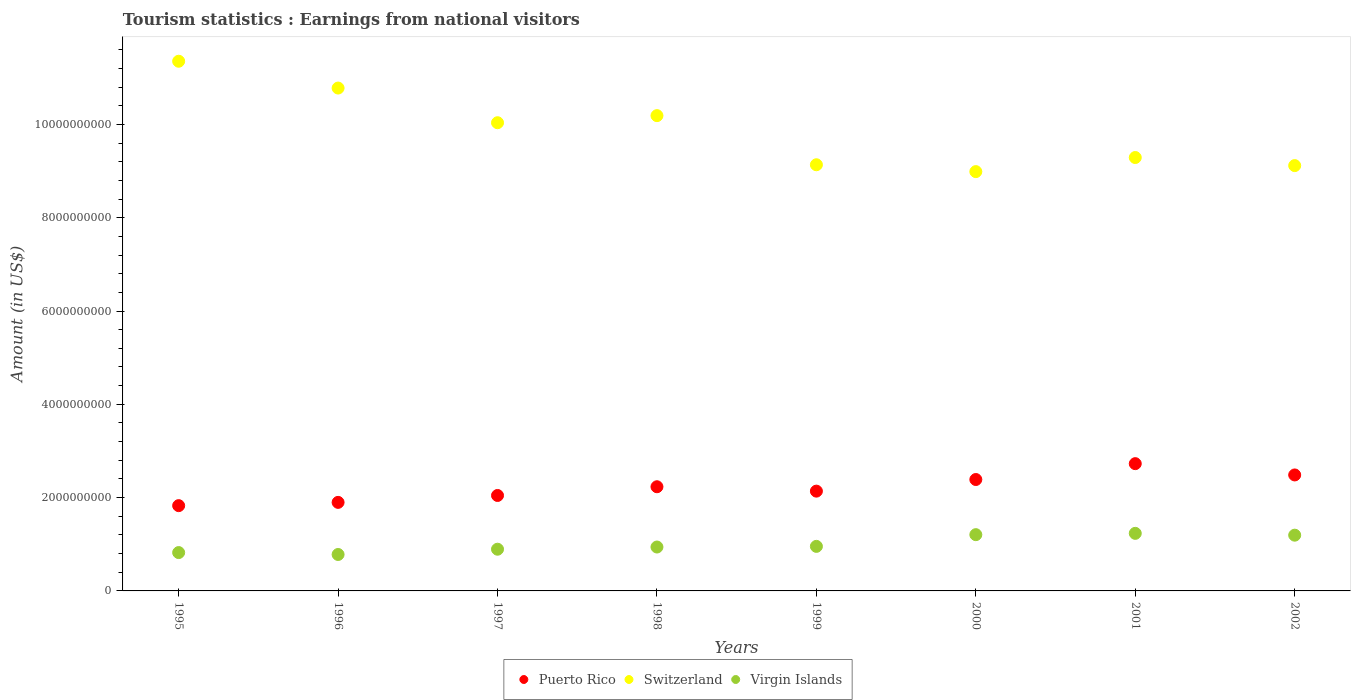How many different coloured dotlines are there?
Make the answer very short. 3. What is the earnings from national visitors in Puerto Rico in 2002?
Make the answer very short. 2.49e+09. Across all years, what is the maximum earnings from national visitors in Puerto Rico?
Your response must be concise. 2.73e+09. Across all years, what is the minimum earnings from national visitors in Puerto Rico?
Keep it short and to the point. 1.83e+09. In which year was the earnings from national visitors in Virgin Islands maximum?
Provide a succinct answer. 2001. What is the total earnings from national visitors in Puerto Rico in the graph?
Ensure brevity in your answer.  1.77e+1. What is the difference between the earnings from national visitors in Puerto Rico in 1999 and that in 2000?
Provide a succinct answer. -2.49e+08. What is the difference between the earnings from national visitors in Puerto Rico in 1995 and the earnings from national visitors in Switzerland in 2000?
Provide a short and direct response. -7.16e+09. What is the average earnings from national visitors in Virgin Islands per year?
Your answer should be compact. 1.00e+09. In the year 1996, what is the difference between the earnings from national visitors in Virgin Islands and earnings from national visitors in Switzerland?
Provide a short and direct response. -1.00e+1. What is the ratio of the earnings from national visitors in Switzerland in 1995 to that in 1999?
Provide a short and direct response. 1.24. Is the earnings from national visitors in Puerto Rico in 1996 less than that in 2001?
Provide a short and direct response. Yes. What is the difference between the highest and the second highest earnings from national visitors in Virgin Islands?
Make the answer very short. 2.80e+07. What is the difference between the highest and the lowest earnings from national visitors in Virgin Islands?
Give a very brief answer. 4.53e+08. In how many years, is the earnings from national visitors in Switzerland greater than the average earnings from national visitors in Switzerland taken over all years?
Your answer should be very brief. 4. Is it the case that in every year, the sum of the earnings from national visitors in Virgin Islands and earnings from national visitors in Switzerland  is greater than the earnings from national visitors in Puerto Rico?
Give a very brief answer. Yes. Is the earnings from national visitors in Switzerland strictly less than the earnings from national visitors in Virgin Islands over the years?
Make the answer very short. No. How many dotlines are there?
Make the answer very short. 3. How many years are there in the graph?
Your answer should be compact. 8. What is the difference between two consecutive major ticks on the Y-axis?
Provide a succinct answer. 2.00e+09. Does the graph contain any zero values?
Ensure brevity in your answer.  No. Where does the legend appear in the graph?
Ensure brevity in your answer.  Bottom center. What is the title of the graph?
Your answer should be very brief. Tourism statistics : Earnings from national visitors. What is the Amount (in US$) in Puerto Rico in 1995?
Offer a terse response. 1.83e+09. What is the Amount (in US$) in Switzerland in 1995?
Keep it short and to the point. 1.14e+1. What is the Amount (in US$) in Virgin Islands in 1995?
Make the answer very short. 8.22e+08. What is the Amount (in US$) in Puerto Rico in 1996?
Offer a terse response. 1.90e+09. What is the Amount (in US$) in Switzerland in 1996?
Make the answer very short. 1.08e+1. What is the Amount (in US$) of Virgin Islands in 1996?
Provide a short and direct response. 7.81e+08. What is the Amount (in US$) in Puerto Rico in 1997?
Offer a very short reply. 2.05e+09. What is the Amount (in US$) in Switzerland in 1997?
Offer a terse response. 1.00e+1. What is the Amount (in US$) in Virgin Islands in 1997?
Provide a succinct answer. 8.94e+08. What is the Amount (in US$) of Puerto Rico in 1998?
Provide a succinct answer. 2.23e+09. What is the Amount (in US$) of Switzerland in 1998?
Make the answer very short. 1.02e+1. What is the Amount (in US$) in Virgin Islands in 1998?
Provide a succinct answer. 9.41e+08. What is the Amount (in US$) of Puerto Rico in 1999?
Your response must be concise. 2.14e+09. What is the Amount (in US$) in Switzerland in 1999?
Provide a short and direct response. 9.14e+09. What is the Amount (in US$) of Virgin Islands in 1999?
Give a very brief answer. 9.55e+08. What is the Amount (in US$) in Puerto Rico in 2000?
Offer a terse response. 2.39e+09. What is the Amount (in US$) of Switzerland in 2000?
Offer a terse response. 8.99e+09. What is the Amount (in US$) of Virgin Islands in 2000?
Your answer should be compact. 1.21e+09. What is the Amount (in US$) in Puerto Rico in 2001?
Keep it short and to the point. 2.73e+09. What is the Amount (in US$) in Switzerland in 2001?
Offer a very short reply. 9.29e+09. What is the Amount (in US$) in Virgin Islands in 2001?
Your answer should be very brief. 1.23e+09. What is the Amount (in US$) of Puerto Rico in 2002?
Your response must be concise. 2.49e+09. What is the Amount (in US$) of Switzerland in 2002?
Provide a succinct answer. 9.12e+09. What is the Amount (in US$) of Virgin Islands in 2002?
Your response must be concise. 1.20e+09. Across all years, what is the maximum Amount (in US$) in Puerto Rico?
Offer a terse response. 2.73e+09. Across all years, what is the maximum Amount (in US$) in Switzerland?
Your response must be concise. 1.14e+1. Across all years, what is the maximum Amount (in US$) of Virgin Islands?
Offer a very short reply. 1.23e+09. Across all years, what is the minimum Amount (in US$) in Puerto Rico?
Your answer should be very brief. 1.83e+09. Across all years, what is the minimum Amount (in US$) in Switzerland?
Give a very brief answer. 8.99e+09. Across all years, what is the minimum Amount (in US$) in Virgin Islands?
Provide a succinct answer. 7.81e+08. What is the total Amount (in US$) of Puerto Rico in the graph?
Your answer should be very brief. 1.77e+1. What is the total Amount (in US$) in Switzerland in the graph?
Provide a succinct answer. 7.89e+1. What is the total Amount (in US$) in Virgin Islands in the graph?
Provide a short and direct response. 8.03e+09. What is the difference between the Amount (in US$) of Puerto Rico in 1995 and that in 1996?
Provide a short and direct response. -7.00e+07. What is the difference between the Amount (in US$) in Switzerland in 1995 and that in 1996?
Provide a succinct answer. 5.75e+08. What is the difference between the Amount (in US$) in Virgin Islands in 1995 and that in 1996?
Offer a terse response. 4.10e+07. What is the difference between the Amount (in US$) of Puerto Rico in 1995 and that in 1997?
Offer a terse response. -2.18e+08. What is the difference between the Amount (in US$) in Switzerland in 1995 and that in 1997?
Offer a very short reply. 1.32e+09. What is the difference between the Amount (in US$) of Virgin Islands in 1995 and that in 1997?
Make the answer very short. -7.20e+07. What is the difference between the Amount (in US$) in Puerto Rico in 1995 and that in 1998?
Ensure brevity in your answer.  -4.05e+08. What is the difference between the Amount (in US$) of Switzerland in 1995 and that in 1998?
Ensure brevity in your answer.  1.17e+09. What is the difference between the Amount (in US$) of Virgin Islands in 1995 and that in 1998?
Your answer should be compact. -1.19e+08. What is the difference between the Amount (in US$) in Puerto Rico in 1995 and that in 1999?
Keep it short and to the point. -3.11e+08. What is the difference between the Amount (in US$) of Switzerland in 1995 and that in 1999?
Make the answer very short. 2.22e+09. What is the difference between the Amount (in US$) of Virgin Islands in 1995 and that in 1999?
Your answer should be compact. -1.33e+08. What is the difference between the Amount (in US$) in Puerto Rico in 1995 and that in 2000?
Your answer should be compact. -5.60e+08. What is the difference between the Amount (in US$) in Switzerland in 1995 and that in 2000?
Offer a very short reply. 2.37e+09. What is the difference between the Amount (in US$) of Virgin Islands in 1995 and that in 2000?
Your response must be concise. -3.84e+08. What is the difference between the Amount (in US$) in Puerto Rico in 1995 and that in 2001?
Provide a succinct answer. -9.00e+08. What is the difference between the Amount (in US$) in Switzerland in 1995 and that in 2001?
Offer a terse response. 2.06e+09. What is the difference between the Amount (in US$) of Virgin Islands in 1995 and that in 2001?
Make the answer very short. -4.12e+08. What is the difference between the Amount (in US$) in Puerto Rico in 1995 and that in 2002?
Give a very brief answer. -6.58e+08. What is the difference between the Amount (in US$) in Switzerland in 1995 and that in 2002?
Your response must be concise. 2.24e+09. What is the difference between the Amount (in US$) of Virgin Islands in 1995 and that in 2002?
Keep it short and to the point. -3.73e+08. What is the difference between the Amount (in US$) in Puerto Rico in 1996 and that in 1997?
Your response must be concise. -1.48e+08. What is the difference between the Amount (in US$) of Switzerland in 1996 and that in 1997?
Make the answer very short. 7.43e+08. What is the difference between the Amount (in US$) of Virgin Islands in 1996 and that in 1997?
Keep it short and to the point. -1.13e+08. What is the difference between the Amount (in US$) in Puerto Rico in 1996 and that in 1998?
Offer a terse response. -3.35e+08. What is the difference between the Amount (in US$) in Switzerland in 1996 and that in 1998?
Keep it short and to the point. 5.91e+08. What is the difference between the Amount (in US$) in Virgin Islands in 1996 and that in 1998?
Your answer should be very brief. -1.60e+08. What is the difference between the Amount (in US$) of Puerto Rico in 1996 and that in 1999?
Ensure brevity in your answer.  -2.41e+08. What is the difference between the Amount (in US$) in Switzerland in 1996 and that in 1999?
Provide a short and direct response. 1.64e+09. What is the difference between the Amount (in US$) in Virgin Islands in 1996 and that in 1999?
Your answer should be very brief. -1.74e+08. What is the difference between the Amount (in US$) of Puerto Rico in 1996 and that in 2000?
Offer a terse response. -4.90e+08. What is the difference between the Amount (in US$) in Switzerland in 1996 and that in 2000?
Provide a succinct answer. 1.79e+09. What is the difference between the Amount (in US$) of Virgin Islands in 1996 and that in 2000?
Ensure brevity in your answer.  -4.25e+08. What is the difference between the Amount (in US$) of Puerto Rico in 1996 and that in 2001?
Offer a very short reply. -8.30e+08. What is the difference between the Amount (in US$) in Switzerland in 1996 and that in 2001?
Provide a short and direct response. 1.49e+09. What is the difference between the Amount (in US$) in Virgin Islands in 1996 and that in 2001?
Your answer should be very brief. -4.53e+08. What is the difference between the Amount (in US$) in Puerto Rico in 1996 and that in 2002?
Your answer should be very brief. -5.88e+08. What is the difference between the Amount (in US$) of Switzerland in 1996 and that in 2002?
Your response must be concise. 1.66e+09. What is the difference between the Amount (in US$) of Virgin Islands in 1996 and that in 2002?
Offer a very short reply. -4.14e+08. What is the difference between the Amount (in US$) of Puerto Rico in 1997 and that in 1998?
Keep it short and to the point. -1.87e+08. What is the difference between the Amount (in US$) of Switzerland in 1997 and that in 1998?
Make the answer very short. -1.52e+08. What is the difference between the Amount (in US$) of Virgin Islands in 1997 and that in 1998?
Ensure brevity in your answer.  -4.70e+07. What is the difference between the Amount (in US$) of Puerto Rico in 1997 and that in 1999?
Offer a very short reply. -9.30e+07. What is the difference between the Amount (in US$) of Switzerland in 1997 and that in 1999?
Your answer should be compact. 9.01e+08. What is the difference between the Amount (in US$) in Virgin Islands in 1997 and that in 1999?
Offer a very short reply. -6.10e+07. What is the difference between the Amount (in US$) of Puerto Rico in 1997 and that in 2000?
Provide a short and direct response. -3.42e+08. What is the difference between the Amount (in US$) of Switzerland in 1997 and that in 2000?
Provide a succinct answer. 1.05e+09. What is the difference between the Amount (in US$) in Virgin Islands in 1997 and that in 2000?
Provide a succinct answer. -3.12e+08. What is the difference between the Amount (in US$) of Puerto Rico in 1997 and that in 2001?
Give a very brief answer. -6.82e+08. What is the difference between the Amount (in US$) in Switzerland in 1997 and that in 2001?
Your response must be concise. 7.46e+08. What is the difference between the Amount (in US$) in Virgin Islands in 1997 and that in 2001?
Your answer should be very brief. -3.40e+08. What is the difference between the Amount (in US$) of Puerto Rico in 1997 and that in 2002?
Your answer should be very brief. -4.40e+08. What is the difference between the Amount (in US$) of Switzerland in 1997 and that in 2002?
Offer a very short reply. 9.19e+08. What is the difference between the Amount (in US$) in Virgin Islands in 1997 and that in 2002?
Provide a short and direct response. -3.01e+08. What is the difference between the Amount (in US$) of Puerto Rico in 1998 and that in 1999?
Your answer should be compact. 9.40e+07. What is the difference between the Amount (in US$) in Switzerland in 1998 and that in 1999?
Ensure brevity in your answer.  1.05e+09. What is the difference between the Amount (in US$) of Virgin Islands in 1998 and that in 1999?
Provide a short and direct response. -1.40e+07. What is the difference between the Amount (in US$) of Puerto Rico in 1998 and that in 2000?
Ensure brevity in your answer.  -1.55e+08. What is the difference between the Amount (in US$) of Switzerland in 1998 and that in 2000?
Offer a terse response. 1.20e+09. What is the difference between the Amount (in US$) of Virgin Islands in 1998 and that in 2000?
Your response must be concise. -2.65e+08. What is the difference between the Amount (in US$) in Puerto Rico in 1998 and that in 2001?
Offer a very short reply. -4.95e+08. What is the difference between the Amount (in US$) in Switzerland in 1998 and that in 2001?
Ensure brevity in your answer.  8.98e+08. What is the difference between the Amount (in US$) of Virgin Islands in 1998 and that in 2001?
Offer a terse response. -2.93e+08. What is the difference between the Amount (in US$) of Puerto Rico in 1998 and that in 2002?
Offer a terse response. -2.53e+08. What is the difference between the Amount (in US$) in Switzerland in 1998 and that in 2002?
Provide a succinct answer. 1.07e+09. What is the difference between the Amount (in US$) of Virgin Islands in 1998 and that in 2002?
Give a very brief answer. -2.54e+08. What is the difference between the Amount (in US$) in Puerto Rico in 1999 and that in 2000?
Offer a very short reply. -2.49e+08. What is the difference between the Amount (in US$) in Switzerland in 1999 and that in 2000?
Your answer should be very brief. 1.47e+08. What is the difference between the Amount (in US$) in Virgin Islands in 1999 and that in 2000?
Offer a terse response. -2.51e+08. What is the difference between the Amount (in US$) of Puerto Rico in 1999 and that in 2001?
Keep it short and to the point. -5.89e+08. What is the difference between the Amount (in US$) in Switzerland in 1999 and that in 2001?
Offer a terse response. -1.55e+08. What is the difference between the Amount (in US$) in Virgin Islands in 1999 and that in 2001?
Your answer should be compact. -2.79e+08. What is the difference between the Amount (in US$) of Puerto Rico in 1999 and that in 2002?
Offer a terse response. -3.47e+08. What is the difference between the Amount (in US$) in Switzerland in 1999 and that in 2002?
Give a very brief answer. 1.80e+07. What is the difference between the Amount (in US$) of Virgin Islands in 1999 and that in 2002?
Your answer should be compact. -2.40e+08. What is the difference between the Amount (in US$) of Puerto Rico in 2000 and that in 2001?
Provide a short and direct response. -3.40e+08. What is the difference between the Amount (in US$) in Switzerland in 2000 and that in 2001?
Give a very brief answer. -3.02e+08. What is the difference between the Amount (in US$) in Virgin Islands in 2000 and that in 2001?
Keep it short and to the point. -2.80e+07. What is the difference between the Amount (in US$) in Puerto Rico in 2000 and that in 2002?
Keep it short and to the point. -9.80e+07. What is the difference between the Amount (in US$) of Switzerland in 2000 and that in 2002?
Your response must be concise. -1.29e+08. What is the difference between the Amount (in US$) in Virgin Islands in 2000 and that in 2002?
Your response must be concise. 1.10e+07. What is the difference between the Amount (in US$) in Puerto Rico in 2001 and that in 2002?
Offer a terse response. 2.42e+08. What is the difference between the Amount (in US$) of Switzerland in 2001 and that in 2002?
Give a very brief answer. 1.73e+08. What is the difference between the Amount (in US$) in Virgin Islands in 2001 and that in 2002?
Offer a very short reply. 3.90e+07. What is the difference between the Amount (in US$) of Puerto Rico in 1995 and the Amount (in US$) of Switzerland in 1996?
Offer a terse response. -8.95e+09. What is the difference between the Amount (in US$) of Puerto Rico in 1995 and the Amount (in US$) of Virgin Islands in 1996?
Keep it short and to the point. 1.05e+09. What is the difference between the Amount (in US$) of Switzerland in 1995 and the Amount (in US$) of Virgin Islands in 1996?
Ensure brevity in your answer.  1.06e+1. What is the difference between the Amount (in US$) in Puerto Rico in 1995 and the Amount (in US$) in Switzerland in 1997?
Make the answer very short. -8.21e+09. What is the difference between the Amount (in US$) in Puerto Rico in 1995 and the Amount (in US$) in Virgin Islands in 1997?
Offer a terse response. 9.34e+08. What is the difference between the Amount (in US$) of Switzerland in 1995 and the Amount (in US$) of Virgin Islands in 1997?
Provide a succinct answer. 1.05e+1. What is the difference between the Amount (in US$) of Puerto Rico in 1995 and the Amount (in US$) of Switzerland in 1998?
Make the answer very short. -8.36e+09. What is the difference between the Amount (in US$) in Puerto Rico in 1995 and the Amount (in US$) in Virgin Islands in 1998?
Ensure brevity in your answer.  8.87e+08. What is the difference between the Amount (in US$) in Switzerland in 1995 and the Amount (in US$) in Virgin Islands in 1998?
Ensure brevity in your answer.  1.04e+1. What is the difference between the Amount (in US$) of Puerto Rico in 1995 and the Amount (in US$) of Switzerland in 1999?
Offer a very short reply. -7.31e+09. What is the difference between the Amount (in US$) in Puerto Rico in 1995 and the Amount (in US$) in Virgin Islands in 1999?
Provide a succinct answer. 8.73e+08. What is the difference between the Amount (in US$) of Switzerland in 1995 and the Amount (in US$) of Virgin Islands in 1999?
Provide a succinct answer. 1.04e+1. What is the difference between the Amount (in US$) in Puerto Rico in 1995 and the Amount (in US$) in Switzerland in 2000?
Give a very brief answer. -7.16e+09. What is the difference between the Amount (in US$) in Puerto Rico in 1995 and the Amount (in US$) in Virgin Islands in 2000?
Keep it short and to the point. 6.22e+08. What is the difference between the Amount (in US$) of Switzerland in 1995 and the Amount (in US$) of Virgin Islands in 2000?
Offer a very short reply. 1.01e+1. What is the difference between the Amount (in US$) of Puerto Rico in 1995 and the Amount (in US$) of Switzerland in 2001?
Provide a succinct answer. -7.46e+09. What is the difference between the Amount (in US$) in Puerto Rico in 1995 and the Amount (in US$) in Virgin Islands in 2001?
Offer a very short reply. 5.94e+08. What is the difference between the Amount (in US$) in Switzerland in 1995 and the Amount (in US$) in Virgin Islands in 2001?
Offer a very short reply. 1.01e+1. What is the difference between the Amount (in US$) of Puerto Rico in 1995 and the Amount (in US$) of Switzerland in 2002?
Ensure brevity in your answer.  -7.29e+09. What is the difference between the Amount (in US$) of Puerto Rico in 1995 and the Amount (in US$) of Virgin Islands in 2002?
Offer a very short reply. 6.33e+08. What is the difference between the Amount (in US$) in Switzerland in 1995 and the Amount (in US$) in Virgin Islands in 2002?
Your answer should be compact. 1.02e+1. What is the difference between the Amount (in US$) in Puerto Rico in 1996 and the Amount (in US$) in Switzerland in 1997?
Offer a very short reply. -8.14e+09. What is the difference between the Amount (in US$) in Puerto Rico in 1996 and the Amount (in US$) in Virgin Islands in 1997?
Provide a succinct answer. 1.00e+09. What is the difference between the Amount (in US$) of Switzerland in 1996 and the Amount (in US$) of Virgin Islands in 1997?
Make the answer very short. 9.88e+09. What is the difference between the Amount (in US$) in Puerto Rico in 1996 and the Amount (in US$) in Switzerland in 1998?
Provide a succinct answer. -8.29e+09. What is the difference between the Amount (in US$) of Puerto Rico in 1996 and the Amount (in US$) of Virgin Islands in 1998?
Your response must be concise. 9.57e+08. What is the difference between the Amount (in US$) in Switzerland in 1996 and the Amount (in US$) in Virgin Islands in 1998?
Provide a succinct answer. 9.84e+09. What is the difference between the Amount (in US$) of Puerto Rico in 1996 and the Amount (in US$) of Switzerland in 1999?
Keep it short and to the point. -7.24e+09. What is the difference between the Amount (in US$) of Puerto Rico in 1996 and the Amount (in US$) of Virgin Islands in 1999?
Offer a terse response. 9.43e+08. What is the difference between the Amount (in US$) in Switzerland in 1996 and the Amount (in US$) in Virgin Islands in 1999?
Ensure brevity in your answer.  9.82e+09. What is the difference between the Amount (in US$) in Puerto Rico in 1996 and the Amount (in US$) in Switzerland in 2000?
Your answer should be compact. -7.09e+09. What is the difference between the Amount (in US$) in Puerto Rico in 1996 and the Amount (in US$) in Virgin Islands in 2000?
Offer a very short reply. 6.92e+08. What is the difference between the Amount (in US$) in Switzerland in 1996 and the Amount (in US$) in Virgin Islands in 2000?
Provide a short and direct response. 9.57e+09. What is the difference between the Amount (in US$) of Puerto Rico in 1996 and the Amount (in US$) of Switzerland in 2001?
Ensure brevity in your answer.  -7.39e+09. What is the difference between the Amount (in US$) in Puerto Rico in 1996 and the Amount (in US$) in Virgin Islands in 2001?
Your response must be concise. 6.64e+08. What is the difference between the Amount (in US$) in Switzerland in 1996 and the Amount (in US$) in Virgin Islands in 2001?
Your answer should be compact. 9.54e+09. What is the difference between the Amount (in US$) in Puerto Rico in 1996 and the Amount (in US$) in Switzerland in 2002?
Offer a terse response. -7.22e+09. What is the difference between the Amount (in US$) of Puerto Rico in 1996 and the Amount (in US$) of Virgin Islands in 2002?
Ensure brevity in your answer.  7.03e+08. What is the difference between the Amount (in US$) in Switzerland in 1996 and the Amount (in US$) in Virgin Islands in 2002?
Ensure brevity in your answer.  9.58e+09. What is the difference between the Amount (in US$) of Puerto Rico in 1997 and the Amount (in US$) of Switzerland in 1998?
Make the answer very short. -8.14e+09. What is the difference between the Amount (in US$) of Puerto Rico in 1997 and the Amount (in US$) of Virgin Islands in 1998?
Your answer should be compact. 1.10e+09. What is the difference between the Amount (in US$) of Switzerland in 1997 and the Amount (in US$) of Virgin Islands in 1998?
Provide a succinct answer. 9.10e+09. What is the difference between the Amount (in US$) in Puerto Rico in 1997 and the Amount (in US$) in Switzerland in 1999?
Your response must be concise. -7.09e+09. What is the difference between the Amount (in US$) of Puerto Rico in 1997 and the Amount (in US$) of Virgin Islands in 1999?
Offer a very short reply. 1.09e+09. What is the difference between the Amount (in US$) of Switzerland in 1997 and the Amount (in US$) of Virgin Islands in 1999?
Your answer should be compact. 9.08e+09. What is the difference between the Amount (in US$) of Puerto Rico in 1997 and the Amount (in US$) of Switzerland in 2000?
Provide a succinct answer. -6.94e+09. What is the difference between the Amount (in US$) in Puerto Rico in 1997 and the Amount (in US$) in Virgin Islands in 2000?
Provide a short and direct response. 8.40e+08. What is the difference between the Amount (in US$) in Switzerland in 1997 and the Amount (in US$) in Virgin Islands in 2000?
Give a very brief answer. 8.83e+09. What is the difference between the Amount (in US$) of Puerto Rico in 1997 and the Amount (in US$) of Switzerland in 2001?
Ensure brevity in your answer.  -7.24e+09. What is the difference between the Amount (in US$) of Puerto Rico in 1997 and the Amount (in US$) of Virgin Islands in 2001?
Your answer should be very brief. 8.12e+08. What is the difference between the Amount (in US$) in Switzerland in 1997 and the Amount (in US$) in Virgin Islands in 2001?
Make the answer very short. 8.80e+09. What is the difference between the Amount (in US$) of Puerto Rico in 1997 and the Amount (in US$) of Switzerland in 2002?
Make the answer very short. -7.07e+09. What is the difference between the Amount (in US$) in Puerto Rico in 1997 and the Amount (in US$) in Virgin Islands in 2002?
Your response must be concise. 8.51e+08. What is the difference between the Amount (in US$) of Switzerland in 1997 and the Amount (in US$) of Virgin Islands in 2002?
Provide a succinct answer. 8.84e+09. What is the difference between the Amount (in US$) in Puerto Rico in 1998 and the Amount (in US$) in Switzerland in 1999?
Provide a succinct answer. -6.90e+09. What is the difference between the Amount (in US$) of Puerto Rico in 1998 and the Amount (in US$) of Virgin Islands in 1999?
Your answer should be very brief. 1.28e+09. What is the difference between the Amount (in US$) of Switzerland in 1998 and the Amount (in US$) of Virgin Islands in 1999?
Your answer should be compact. 9.23e+09. What is the difference between the Amount (in US$) in Puerto Rico in 1998 and the Amount (in US$) in Switzerland in 2000?
Your answer should be very brief. -6.76e+09. What is the difference between the Amount (in US$) of Puerto Rico in 1998 and the Amount (in US$) of Virgin Islands in 2000?
Keep it short and to the point. 1.03e+09. What is the difference between the Amount (in US$) of Switzerland in 1998 and the Amount (in US$) of Virgin Islands in 2000?
Your response must be concise. 8.98e+09. What is the difference between the Amount (in US$) in Puerto Rico in 1998 and the Amount (in US$) in Switzerland in 2001?
Give a very brief answer. -7.06e+09. What is the difference between the Amount (in US$) in Puerto Rico in 1998 and the Amount (in US$) in Virgin Islands in 2001?
Your answer should be very brief. 9.99e+08. What is the difference between the Amount (in US$) in Switzerland in 1998 and the Amount (in US$) in Virgin Islands in 2001?
Provide a short and direct response. 8.95e+09. What is the difference between the Amount (in US$) in Puerto Rico in 1998 and the Amount (in US$) in Switzerland in 2002?
Offer a very short reply. -6.88e+09. What is the difference between the Amount (in US$) in Puerto Rico in 1998 and the Amount (in US$) in Virgin Islands in 2002?
Your answer should be compact. 1.04e+09. What is the difference between the Amount (in US$) in Switzerland in 1998 and the Amount (in US$) in Virgin Islands in 2002?
Offer a terse response. 8.99e+09. What is the difference between the Amount (in US$) of Puerto Rico in 1999 and the Amount (in US$) of Switzerland in 2000?
Give a very brief answer. -6.85e+09. What is the difference between the Amount (in US$) in Puerto Rico in 1999 and the Amount (in US$) in Virgin Islands in 2000?
Provide a short and direct response. 9.33e+08. What is the difference between the Amount (in US$) in Switzerland in 1999 and the Amount (in US$) in Virgin Islands in 2000?
Keep it short and to the point. 7.93e+09. What is the difference between the Amount (in US$) of Puerto Rico in 1999 and the Amount (in US$) of Switzerland in 2001?
Give a very brief answer. -7.15e+09. What is the difference between the Amount (in US$) in Puerto Rico in 1999 and the Amount (in US$) in Virgin Islands in 2001?
Your response must be concise. 9.05e+08. What is the difference between the Amount (in US$) of Switzerland in 1999 and the Amount (in US$) of Virgin Islands in 2001?
Offer a very short reply. 7.90e+09. What is the difference between the Amount (in US$) in Puerto Rico in 1999 and the Amount (in US$) in Switzerland in 2002?
Offer a terse response. -6.98e+09. What is the difference between the Amount (in US$) in Puerto Rico in 1999 and the Amount (in US$) in Virgin Islands in 2002?
Offer a terse response. 9.44e+08. What is the difference between the Amount (in US$) of Switzerland in 1999 and the Amount (in US$) of Virgin Islands in 2002?
Make the answer very short. 7.94e+09. What is the difference between the Amount (in US$) in Puerto Rico in 2000 and the Amount (in US$) in Switzerland in 2001?
Your response must be concise. -6.90e+09. What is the difference between the Amount (in US$) of Puerto Rico in 2000 and the Amount (in US$) of Virgin Islands in 2001?
Give a very brief answer. 1.15e+09. What is the difference between the Amount (in US$) of Switzerland in 2000 and the Amount (in US$) of Virgin Islands in 2001?
Ensure brevity in your answer.  7.75e+09. What is the difference between the Amount (in US$) in Puerto Rico in 2000 and the Amount (in US$) in Switzerland in 2002?
Make the answer very short. -6.73e+09. What is the difference between the Amount (in US$) of Puerto Rico in 2000 and the Amount (in US$) of Virgin Islands in 2002?
Your answer should be very brief. 1.19e+09. What is the difference between the Amount (in US$) in Switzerland in 2000 and the Amount (in US$) in Virgin Islands in 2002?
Make the answer very short. 7.79e+09. What is the difference between the Amount (in US$) in Puerto Rico in 2001 and the Amount (in US$) in Switzerland in 2002?
Provide a short and direct response. -6.39e+09. What is the difference between the Amount (in US$) of Puerto Rico in 2001 and the Amount (in US$) of Virgin Islands in 2002?
Your answer should be very brief. 1.53e+09. What is the difference between the Amount (in US$) of Switzerland in 2001 and the Amount (in US$) of Virgin Islands in 2002?
Keep it short and to the point. 8.10e+09. What is the average Amount (in US$) of Puerto Rico per year?
Ensure brevity in your answer.  2.22e+09. What is the average Amount (in US$) of Switzerland per year?
Keep it short and to the point. 9.86e+09. What is the average Amount (in US$) in Virgin Islands per year?
Your answer should be compact. 1.00e+09. In the year 1995, what is the difference between the Amount (in US$) in Puerto Rico and Amount (in US$) in Switzerland?
Keep it short and to the point. -9.53e+09. In the year 1995, what is the difference between the Amount (in US$) of Puerto Rico and Amount (in US$) of Virgin Islands?
Offer a very short reply. 1.01e+09. In the year 1995, what is the difference between the Amount (in US$) in Switzerland and Amount (in US$) in Virgin Islands?
Give a very brief answer. 1.05e+1. In the year 1996, what is the difference between the Amount (in US$) of Puerto Rico and Amount (in US$) of Switzerland?
Ensure brevity in your answer.  -8.88e+09. In the year 1996, what is the difference between the Amount (in US$) in Puerto Rico and Amount (in US$) in Virgin Islands?
Make the answer very short. 1.12e+09. In the year 1996, what is the difference between the Amount (in US$) of Switzerland and Amount (in US$) of Virgin Islands?
Your answer should be compact. 1.00e+1. In the year 1997, what is the difference between the Amount (in US$) in Puerto Rico and Amount (in US$) in Switzerland?
Offer a very short reply. -7.99e+09. In the year 1997, what is the difference between the Amount (in US$) of Puerto Rico and Amount (in US$) of Virgin Islands?
Provide a succinct answer. 1.15e+09. In the year 1997, what is the difference between the Amount (in US$) of Switzerland and Amount (in US$) of Virgin Islands?
Your answer should be very brief. 9.14e+09. In the year 1998, what is the difference between the Amount (in US$) in Puerto Rico and Amount (in US$) in Switzerland?
Your response must be concise. -7.96e+09. In the year 1998, what is the difference between the Amount (in US$) in Puerto Rico and Amount (in US$) in Virgin Islands?
Give a very brief answer. 1.29e+09. In the year 1998, what is the difference between the Amount (in US$) of Switzerland and Amount (in US$) of Virgin Islands?
Provide a short and direct response. 9.25e+09. In the year 1999, what is the difference between the Amount (in US$) in Puerto Rico and Amount (in US$) in Switzerland?
Offer a very short reply. -7.00e+09. In the year 1999, what is the difference between the Amount (in US$) of Puerto Rico and Amount (in US$) of Virgin Islands?
Provide a short and direct response. 1.18e+09. In the year 1999, what is the difference between the Amount (in US$) in Switzerland and Amount (in US$) in Virgin Islands?
Your answer should be compact. 8.18e+09. In the year 2000, what is the difference between the Amount (in US$) in Puerto Rico and Amount (in US$) in Switzerland?
Ensure brevity in your answer.  -6.60e+09. In the year 2000, what is the difference between the Amount (in US$) in Puerto Rico and Amount (in US$) in Virgin Islands?
Make the answer very short. 1.18e+09. In the year 2000, what is the difference between the Amount (in US$) of Switzerland and Amount (in US$) of Virgin Islands?
Offer a very short reply. 7.78e+09. In the year 2001, what is the difference between the Amount (in US$) in Puerto Rico and Amount (in US$) in Switzerland?
Keep it short and to the point. -6.56e+09. In the year 2001, what is the difference between the Amount (in US$) of Puerto Rico and Amount (in US$) of Virgin Islands?
Provide a succinct answer. 1.49e+09. In the year 2001, what is the difference between the Amount (in US$) in Switzerland and Amount (in US$) in Virgin Islands?
Your answer should be compact. 8.06e+09. In the year 2002, what is the difference between the Amount (in US$) in Puerto Rico and Amount (in US$) in Switzerland?
Give a very brief answer. -6.63e+09. In the year 2002, what is the difference between the Amount (in US$) of Puerto Rico and Amount (in US$) of Virgin Islands?
Make the answer very short. 1.29e+09. In the year 2002, what is the difference between the Amount (in US$) of Switzerland and Amount (in US$) of Virgin Islands?
Provide a succinct answer. 7.92e+09. What is the ratio of the Amount (in US$) in Puerto Rico in 1995 to that in 1996?
Your answer should be very brief. 0.96. What is the ratio of the Amount (in US$) in Switzerland in 1995 to that in 1996?
Give a very brief answer. 1.05. What is the ratio of the Amount (in US$) in Virgin Islands in 1995 to that in 1996?
Make the answer very short. 1.05. What is the ratio of the Amount (in US$) of Puerto Rico in 1995 to that in 1997?
Your answer should be very brief. 0.89. What is the ratio of the Amount (in US$) of Switzerland in 1995 to that in 1997?
Ensure brevity in your answer.  1.13. What is the ratio of the Amount (in US$) of Virgin Islands in 1995 to that in 1997?
Ensure brevity in your answer.  0.92. What is the ratio of the Amount (in US$) of Puerto Rico in 1995 to that in 1998?
Give a very brief answer. 0.82. What is the ratio of the Amount (in US$) in Switzerland in 1995 to that in 1998?
Offer a terse response. 1.11. What is the ratio of the Amount (in US$) in Virgin Islands in 1995 to that in 1998?
Offer a terse response. 0.87. What is the ratio of the Amount (in US$) in Puerto Rico in 1995 to that in 1999?
Offer a very short reply. 0.85. What is the ratio of the Amount (in US$) in Switzerland in 1995 to that in 1999?
Provide a succinct answer. 1.24. What is the ratio of the Amount (in US$) in Virgin Islands in 1995 to that in 1999?
Your answer should be very brief. 0.86. What is the ratio of the Amount (in US$) of Puerto Rico in 1995 to that in 2000?
Offer a terse response. 0.77. What is the ratio of the Amount (in US$) in Switzerland in 1995 to that in 2000?
Your answer should be compact. 1.26. What is the ratio of the Amount (in US$) in Virgin Islands in 1995 to that in 2000?
Your answer should be compact. 0.68. What is the ratio of the Amount (in US$) in Puerto Rico in 1995 to that in 2001?
Your response must be concise. 0.67. What is the ratio of the Amount (in US$) in Switzerland in 1995 to that in 2001?
Offer a very short reply. 1.22. What is the ratio of the Amount (in US$) of Virgin Islands in 1995 to that in 2001?
Your answer should be very brief. 0.67. What is the ratio of the Amount (in US$) in Puerto Rico in 1995 to that in 2002?
Your answer should be compact. 0.74. What is the ratio of the Amount (in US$) in Switzerland in 1995 to that in 2002?
Ensure brevity in your answer.  1.25. What is the ratio of the Amount (in US$) in Virgin Islands in 1995 to that in 2002?
Provide a short and direct response. 0.69. What is the ratio of the Amount (in US$) of Puerto Rico in 1996 to that in 1997?
Ensure brevity in your answer.  0.93. What is the ratio of the Amount (in US$) in Switzerland in 1996 to that in 1997?
Provide a short and direct response. 1.07. What is the ratio of the Amount (in US$) of Virgin Islands in 1996 to that in 1997?
Offer a terse response. 0.87. What is the ratio of the Amount (in US$) of Switzerland in 1996 to that in 1998?
Make the answer very short. 1.06. What is the ratio of the Amount (in US$) in Virgin Islands in 1996 to that in 1998?
Make the answer very short. 0.83. What is the ratio of the Amount (in US$) of Puerto Rico in 1996 to that in 1999?
Provide a succinct answer. 0.89. What is the ratio of the Amount (in US$) in Switzerland in 1996 to that in 1999?
Offer a very short reply. 1.18. What is the ratio of the Amount (in US$) of Virgin Islands in 1996 to that in 1999?
Your answer should be very brief. 0.82. What is the ratio of the Amount (in US$) of Puerto Rico in 1996 to that in 2000?
Keep it short and to the point. 0.79. What is the ratio of the Amount (in US$) in Switzerland in 1996 to that in 2000?
Ensure brevity in your answer.  1.2. What is the ratio of the Amount (in US$) of Virgin Islands in 1996 to that in 2000?
Offer a very short reply. 0.65. What is the ratio of the Amount (in US$) of Puerto Rico in 1996 to that in 2001?
Your answer should be very brief. 0.7. What is the ratio of the Amount (in US$) of Switzerland in 1996 to that in 2001?
Give a very brief answer. 1.16. What is the ratio of the Amount (in US$) in Virgin Islands in 1996 to that in 2001?
Keep it short and to the point. 0.63. What is the ratio of the Amount (in US$) in Puerto Rico in 1996 to that in 2002?
Provide a short and direct response. 0.76. What is the ratio of the Amount (in US$) of Switzerland in 1996 to that in 2002?
Ensure brevity in your answer.  1.18. What is the ratio of the Amount (in US$) in Virgin Islands in 1996 to that in 2002?
Give a very brief answer. 0.65. What is the ratio of the Amount (in US$) in Puerto Rico in 1997 to that in 1998?
Offer a terse response. 0.92. What is the ratio of the Amount (in US$) in Switzerland in 1997 to that in 1998?
Offer a very short reply. 0.99. What is the ratio of the Amount (in US$) of Virgin Islands in 1997 to that in 1998?
Keep it short and to the point. 0.95. What is the ratio of the Amount (in US$) of Puerto Rico in 1997 to that in 1999?
Provide a short and direct response. 0.96. What is the ratio of the Amount (in US$) of Switzerland in 1997 to that in 1999?
Your answer should be compact. 1.1. What is the ratio of the Amount (in US$) of Virgin Islands in 1997 to that in 1999?
Keep it short and to the point. 0.94. What is the ratio of the Amount (in US$) in Puerto Rico in 1997 to that in 2000?
Your answer should be very brief. 0.86. What is the ratio of the Amount (in US$) in Switzerland in 1997 to that in 2000?
Ensure brevity in your answer.  1.12. What is the ratio of the Amount (in US$) in Virgin Islands in 1997 to that in 2000?
Provide a short and direct response. 0.74. What is the ratio of the Amount (in US$) in Switzerland in 1997 to that in 2001?
Offer a terse response. 1.08. What is the ratio of the Amount (in US$) of Virgin Islands in 1997 to that in 2001?
Your answer should be compact. 0.72. What is the ratio of the Amount (in US$) of Puerto Rico in 1997 to that in 2002?
Your answer should be very brief. 0.82. What is the ratio of the Amount (in US$) in Switzerland in 1997 to that in 2002?
Make the answer very short. 1.1. What is the ratio of the Amount (in US$) of Virgin Islands in 1997 to that in 2002?
Offer a very short reply. 0.75. What is the ratio of the Amount (in US$) in Puerto Rico in 1998 to that in 1999?
Make the answer very short. 1.04. What is the ratio of the Amount (in US$) in Switzerland in 1998 to that in 1999?
Make the answer very short. 1.12. What is the ratio of the Amount (in US$) in Puerto Rico in 1998 to that in 2000?
Give a very brief answer. 0.94. What is the ratio of the Amount (in US$) in Switzerland in 1998 to that in 2000?
Your answer should be compact. 1.13. What is the ratio of the Amount (in US$) in Virgin Islands in 1998 to that in 2000?
Offer a terse response. 0.78. What is the ratio of the Amount (in US$) of Puerto Rico in 1998 to that in 2001?
Ensure brevity in your answer.  0.82. What is the ratio of the Amount (in US$) in Switzerland in 1998 to that in 2001?
Provide a short and direct response. 1.1. What is the ratio of the Amount (in US$) of Virgin Islands in 1998 to that in 2001?
Offer a terse response. 0.76. What is the ratio of the Amount (in US$) in Puerto Rico in 1998 to that in 2002?
Ensure brevity in your answer.  0.9. What is the ratio of the Amount (in US$) of Switzerland in 1998 to that in 2002?
Offer a terse response. 1.12. What is the ratio of the Amount (in US$) of Virgin Islands in 1998 to that in 2002?
Offer a very short reply. 0.79. What is the ratio of the Amount (in US$) in Puerto Rico in 1999 to that in 2000?
Offer a very short reply. 0.9. What is the ratio of the Amount (in US$) of Switzerland in 1999 to that in 2000?
Offer a terse response. 1.02. What is the ratio of the Amount (in US$) in Virgin Islands in 1999 to that in 2000?
Give a very brief answer. 0.79. What is the ratio of the Amount (in US$) in Puerto Rico in 1999 to that in 2001?
Your response must be concise. 0.78. What is the ratio of the Amount (in US$) in Switzerland in 1999 to that in 2001?
Offer a terse response. 0.98. What is the ratio of the Amount (in US$) of Virgin Islands in 1999 to that in 2001?
Give a very brief answer. 0.77. What is the ratio of the Amount (in US$) of Puerto Rico in 1999 to that in 2002?
Offer a very short reply. 0.86. What is the ratio of the Amount (in US$) in Virgin Islands in 1999 to that in 2002?
Offer a very short reply. 0.8. What is the ratio of the Amount (in US$) in Puerto Rico in 2000 to that in 2001?
Ensure brevity in your answer.  0.88. What is the ratio of the Amount (in US$) in Switzerland in 2000 to that in 2001?
Your answer should be compact. 0.97. What is the ratio of the Amount (in US$) in Virgin Islands in 2000 to that in 2001?
Offer a very short reply. 0.98. What is the ratio of the Amount (in US$) of Puerto Rico in 2000 to that in 2002?
Your response must be concise. 0.96. What is the ratio of the Amount (in US$) in Switzerland in 2000 to that in 2002?
Offer a terse response. 0.99. What is the ratio of the Amount (in US$) in Virgin Islands in 2000 to that in 2002?
Offer a very short reply. 1.01. What is the ratio of the Amount (in US$) in Puerto Rico in 2001 to that in 2002?
Offer a very short reply. 1.1. What is the ratio of the Amount (in US$) in Switzerland in 2001 to that in 2002?
Your response must be concise. 1.02. What is the ratio of the Amount (in US$) of Virgin Islands in 2001 to that in 2002?
Your answer should be very brief. 1.03. What is the difference between the highest and the second highest Amount (in US$) in Puerto Rico?
Your response must be concise. 2.42e+08. What is the difference between the highest and the second highest Amount (in US$) of Switzerland?
Provide a succinct answer. 5.75e+08. What is the difference between the highest and the second highest Amount (in US$) in Virgin Islands?
Make the answer very short. 2.80e+07. What is the difference between the highest and the lowest Amount (in US$) of Puerto Rico?
Ensure brevity in your answer.  9.00e+08. What is the difference between the highest and the lowest Amount (in US$) of Switzerland?
Your answer should be compact. 2.37e+09. What is the difference between the highest and the lowest Amount (in US$) of Virgin Islands?
Make the answer very short. 4.53e+08. 